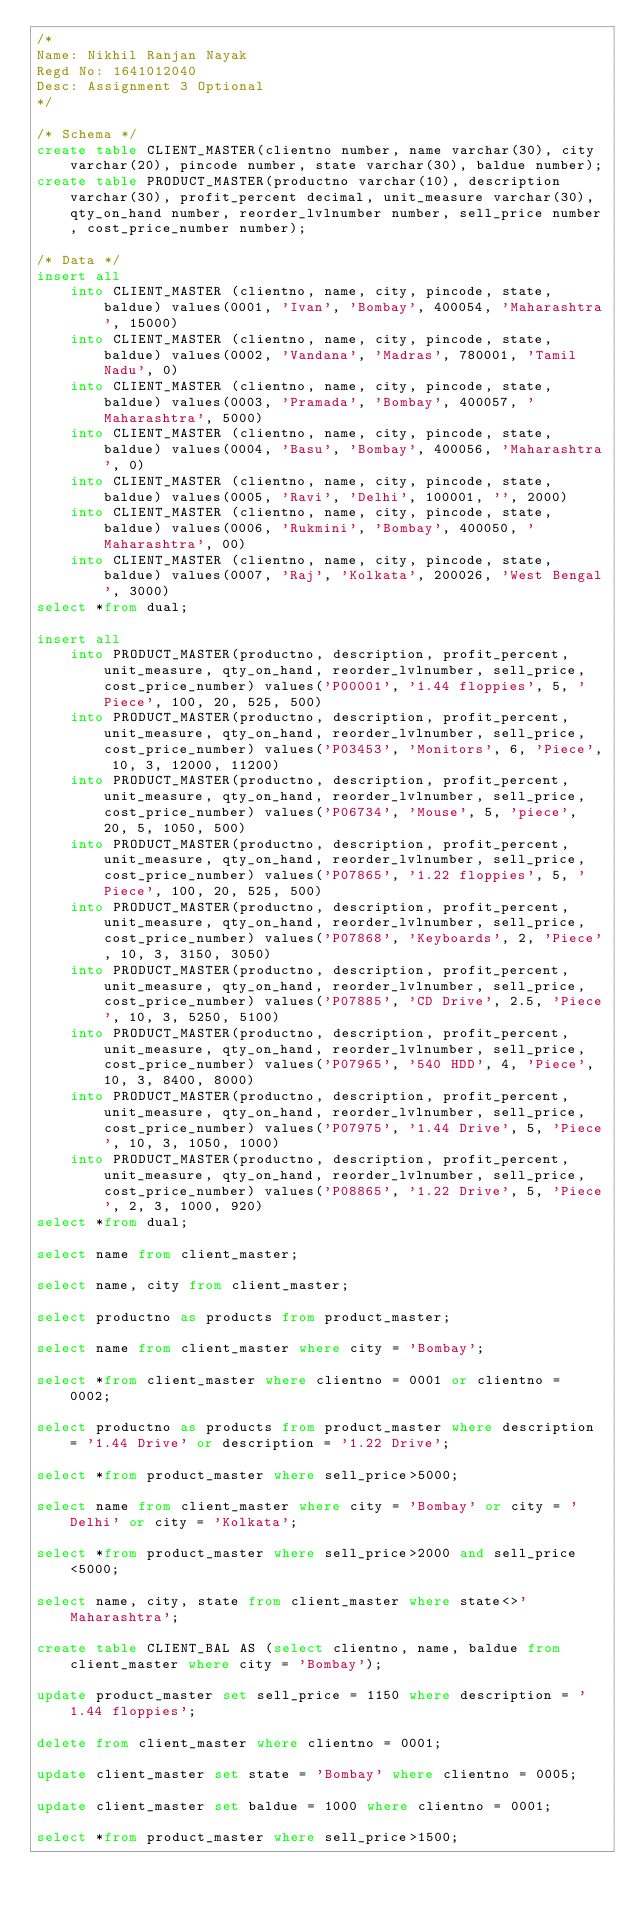<code> <loc_0><loc_0><loc_500><loc_500><_SQL_>/*
Name: Nikhil Ranjan Nayak
Regd No: 1641012040
Desc: Assignment 3 Optional
*/

/* Schema */
create table CLIENT_MASTER(clientno number, name varchar(30), city varchar(20), pincode number, state varchar(30), baldue number);
create table PRODUCT_MASTER(productno varchar(10), description varchar(30), profit_percent decimal, unit_measure varchar(30), qty_on_hand number, reorder_lvlnumber number, sell_price number, cost_price_number number);

/* Data */
insert all
	into CLIENT_MASTER (clientno, name, city, pincode, state, baldue) values(0001, 'Ivan', 'Bombay', 400054, 'Maharashtra', 15000)
	into CLIENT_MASTER (clientno, name, city, pincode, state, baldue) values(0002, 'Vandana', 'Madras', 780001, 'Tamil Nadu', 0)
	into CLIENT_MASTER (clientno, name, city, pincode, state, baldue) values(0003, 'Pramada', 'Bombay', 400057, 'Maharashtra', 5000)
	into CLIENT_MASTER (clientno, name, city, pincode, state, baldue) values(0004, 'Basu', 'Bombay', 400056, 'Maharashtra', 0)
	into CLIENT_MASTER (clientno, name, city, pincode, state, baldue) values(0005, 'Ravi', 'Delhi', 100001, '', 2000)
	into CLIENT_MASTER (clientno, name, city, pincode, state, baldue) values(0006, 'Rukmini', 'Bombay', 400050, 'Maharashtra', 00)
	into CLIENT_MASTER (clientno, name, city, pincode, state, baldue) values(0007, 'Raj', 'Kolkata', 200026, 'West Bengal', 3000)
select *from dual;

insert all
	into PRODUCT_MASTER(productno, description, profit_percent, unit_measure, qty_on_hand, reorder_lvlnumber, sell_price, cost_price_number) values('P00001', '1.44 floppies', 5, 'Piece', 100, 20, 525, 500)
	into PRODUCT_MASTER(productno, description, profit_percent, unit_measure, qty_on_hand, reorder_lvlnumber, sell_price, cost_price_number) values('P03453', 'Monitors', 6, 'Piece', 10, 3, 12000, 11200)
	into PRODUCT_MASTER(productno, description, profit_percent, unit_measure, qty_on_hand, reorder_lvlnumber, sell_price, cost_price_number) values('P06734', 'Mouse', 5, 'piece', 20, 5, 1050, 500)
	into PRODUCT_MASTER(productno, description, profit_percent, unit_measure, qty_on_hand, reorder_lvlnumber, sell_price, cost_price_number) values('P07865', '1.22 floppies', 5, 'Piece', 100, 20, 525, 500)
	into PRODUCT_MASTER(productno, description, profit_percent, unit_measure, qty_on_hand, reorder_lvlnumber, sell_price, cost_price_number) values('P07868', 'Keyboards', 2, 'Piece', 10, 3, 3150, 3050)
	into PRODUCT_MASTER(productno, description, profit_percent, unit_measure, qty_on_hand, reorder_lvlnumber, sell_price, cost_price_number) values('P07885', 'CD Drive', 2.5, 'Piece', 10, 3, 5250, 5100)
	into PRODUCT_MASTER(productno, description, profit_percent, unit_measure, qty_on_hand, reorder_lvlnumber, sell_price, cost_price_number) values('P07965', '540 HDD', 4, 'Piece', 10, 3, 8400, 8000)
	into PRODUCT_MASTER(productno, description, profit_percent, unit_measure, qty_on_hand, reorder_lvlnumber, sell_price, cost_price_number) values('P07975', '1.44 Drive', 5, 'Piece', 10, 3, 1050, 1000)
	into PRODUCT_MASTER(productno, description, profit_percent, unit_measure, qty_on_hand, reorder_lvlnumber, sell_price, cost_price_number) values('P08865', '1.22 Drive', 5, 'Piece', 2, 3, 1000, 920)
select *from dual;

select name from client_master;

select name, city from client_master;

select productno as products from product_master;

select name from client_master where city = 'Bombay';

select *from client_master where clientno = 0001 or clientno = 0002;

select productno as products from product_master where description = '1.44 Drive' or description = '1.22 Drive';

select *from product_master where sell_price>5000;

select name from client_master where city = 'Bombay' or city = 'Delhi' or city = 'Kolkata';

select *from product_master where sell_price>2000 and sell_price<5000;

select name, city, state from client_master where state<>'Maharashtra';

create table CLIENT_BAL AS (select clientno, name, baldue from client_master where city = 'Bombay');

update product_master set sell_price = 1150 where description = '1.44 floppies';

delete from client_master where clientno = 0001;

update client_master set state = 'Bombay' where clientno = 0005;

update client_master set baldue = 1000 where clientno = 0001;

select *from product_master where sell_price>1500;
</code> 